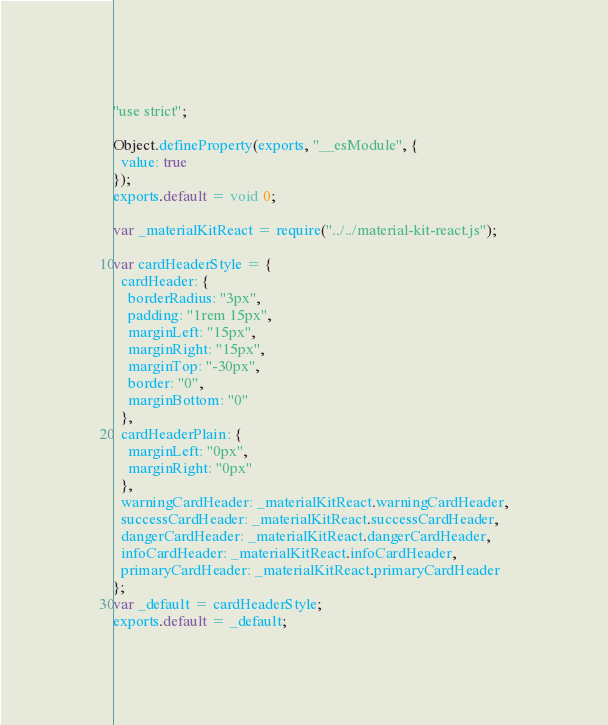Convert code to text. <code><loc_0><loc_0><loc_500><loc_500><_JavaScript_>"use strict";

Object.defineProperty(exports, "__esModule", {
  value: true
});
exports.default = void 0;

var _materialKitReact = require("../../material-kit-react.js");

var cardHeaderStyle = {
  cardHeader: {
    borderRadius: "3px",
    padding: "1rem 15px",
    marginLeft: "15px",
    marginRight: "15px",
    marginTop: "-30px",
    border: "0",
    marginBottom: "0"
  },
  cardHeaderPlain: {
    marginLeft: "0px",
    marginRight: "0px"
  },
  warningCardHeader: _materialKitReact.warningCardHeader,
  successCardHeader: _materialKitReact.successCardHeader,
  dangerCardHeader: _materialKitReact.dangerCardHeader,
  infoCardHeader: _materialKitReact.infoCardHeader,
  primaryCardHeader: _materialKitReact.primaryCardHeader
};
var _default = cardHeaderStyle;
exports.default = _default;</code> 